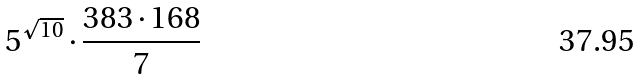Convert formula to latex. <formula><loc_0><loc_0><loc_500><loc_500>5 ^ { \sqrt { 1 0 } } \cdot \frac { 3 8 3 \cdot 1 6 8 } { 7 }</formula> 